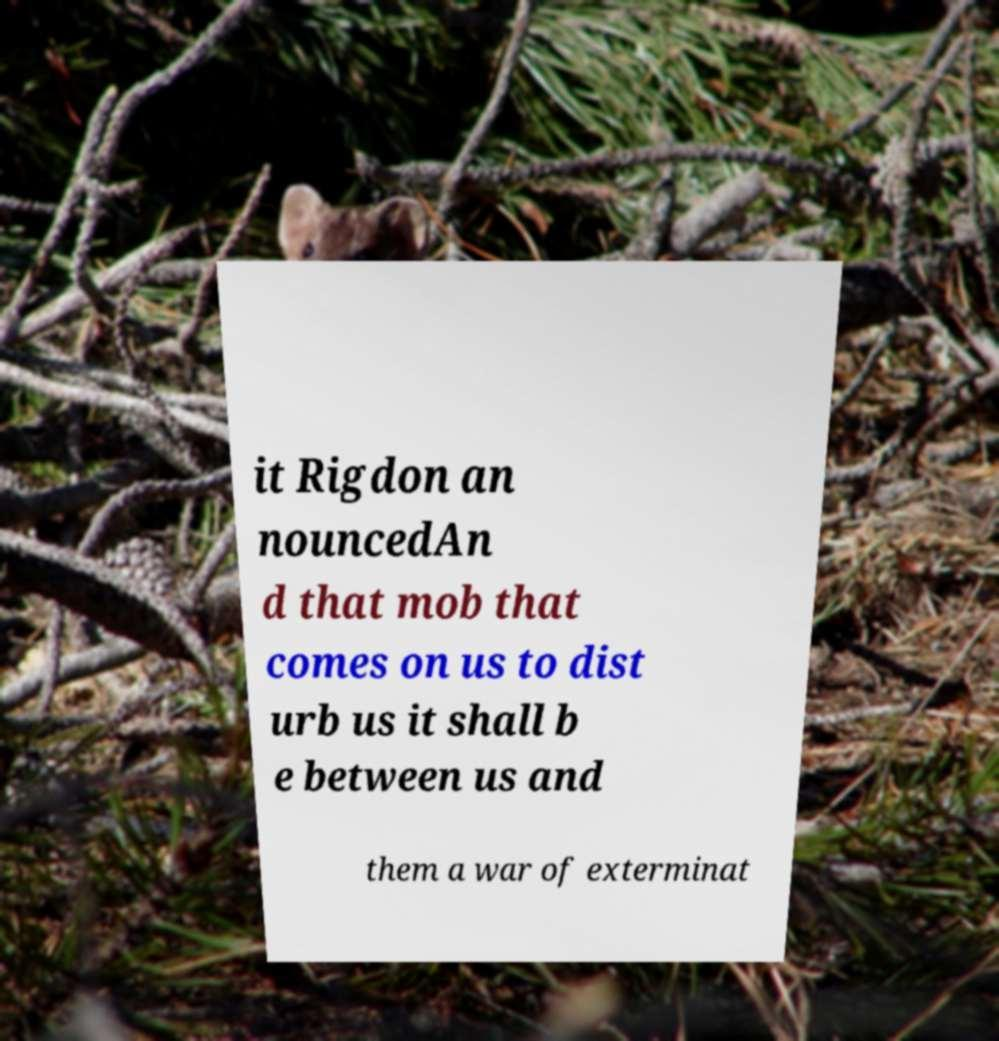There's text embedded in this image that I need extracted. Can you transcribe it verbatim? it Rigdon an nouncedAn d that mob that comes on us to dist urb us it shall b e between us and them a war of exterminat 